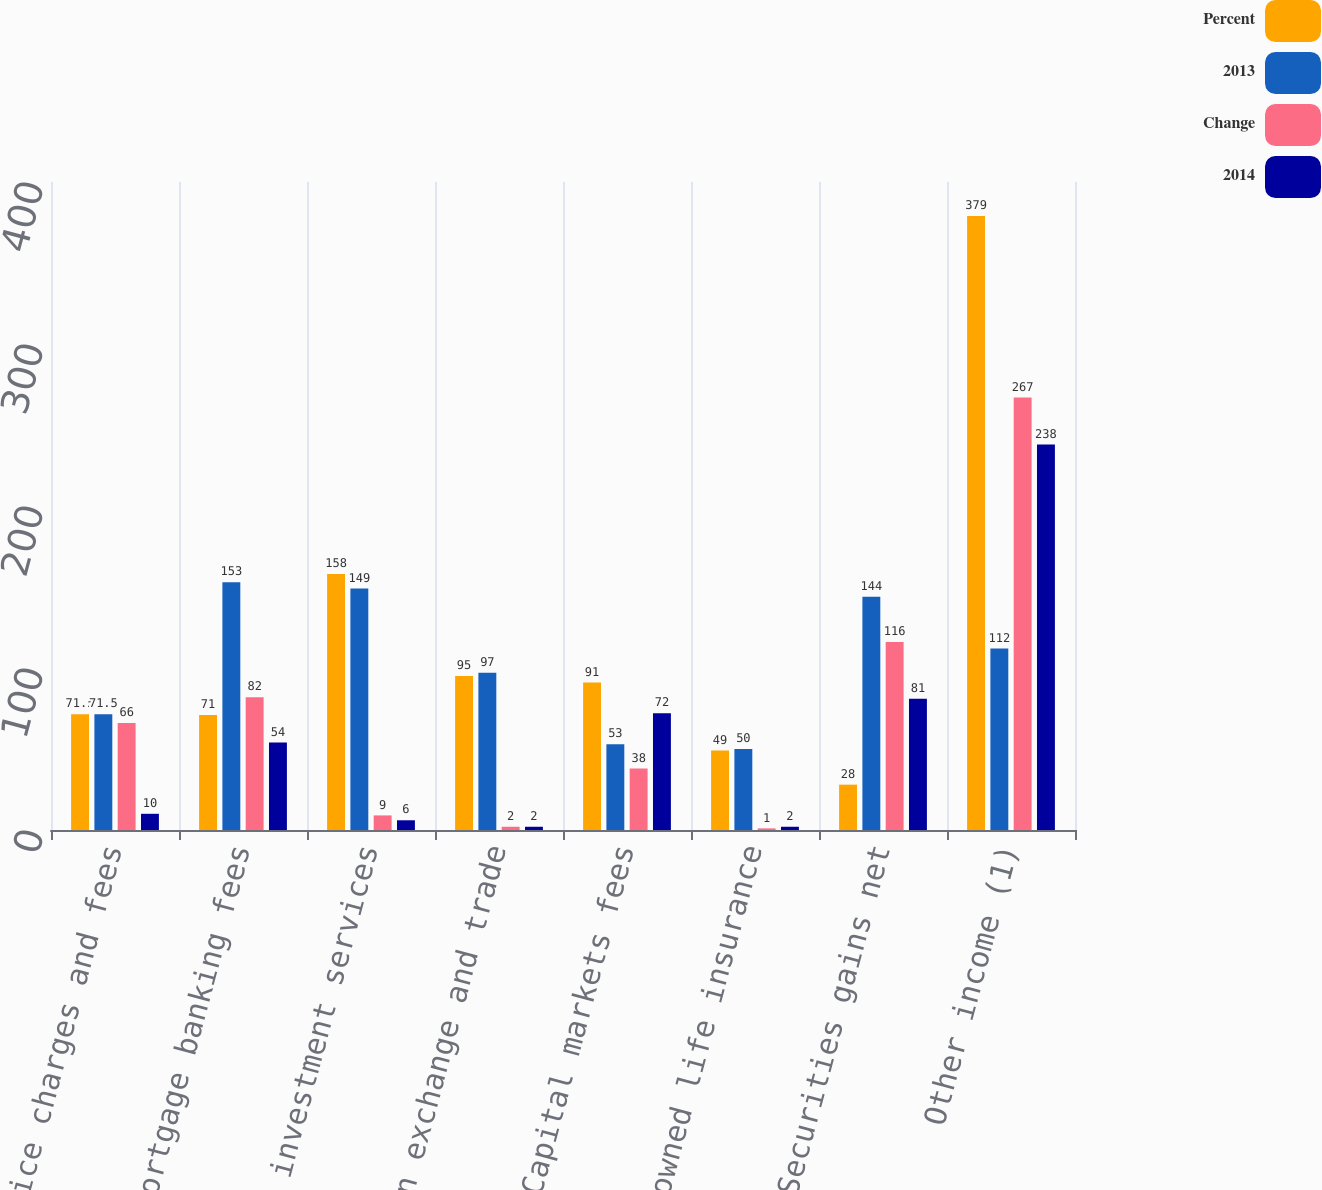Convert chart to OTSL. <chart><loc_0><loc_0><loc_500><loc_500><stacked_bar_chart><ecel><fcel>Service charges and fees<fcel>Mortgage banking fees<fcel>Trust and investment services<fcel>Foreign exchange and trade<fcel>Capital markets fees<fcel>Bank-owned life insurance<fcel>Securities gains net<fcel>Other income (1)<nl><fcel>Percent<fcel>71.5<fcel>71<fcel>158<fcel>95<fcel>91<fcel>49<fcel>28<fcel>379<nl><fcel>2013<fcel>71.5<fcel>153<fcel>149<fcel>97<fcel>53<fcel>50<fcel>144<fcel>112<nl><fcel>Change<fcel>66<fcel>82<fcel>9<fcel>2<fcel>38<fcel>1<fcel>116<fcel>267<nl><fcel>2014<fcel>10<fcel>54<fcel>6<fcel>2<fcel>72<fcel>2<fcel>81<fcel>238<nl></chart> 